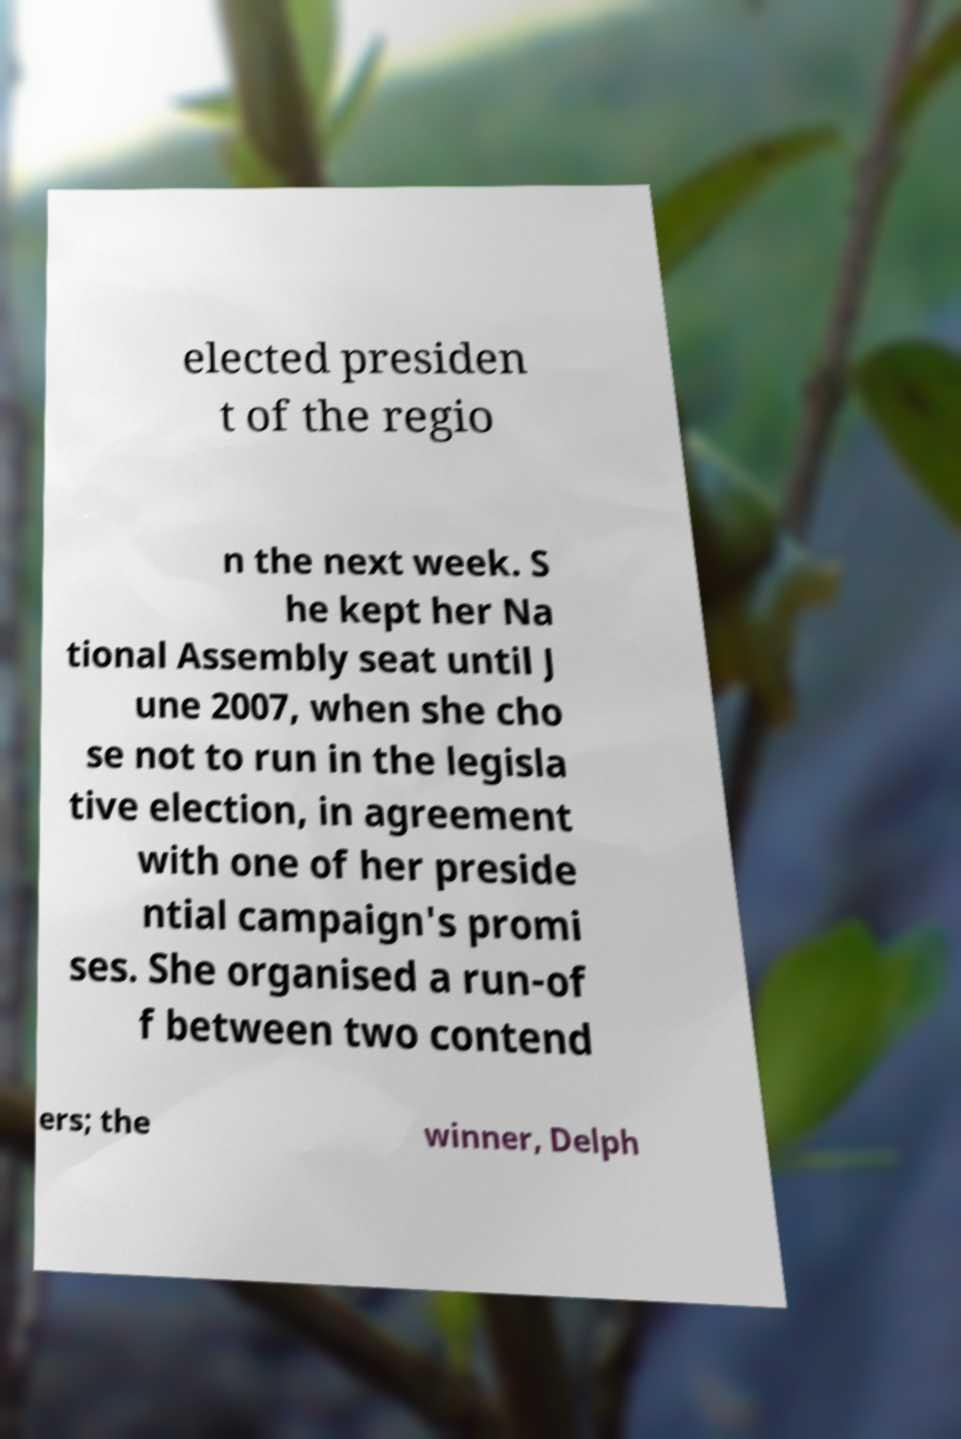Could you extract and type out the text from this image? elected presiden t of the regio n the next week. S he kept her Na tional Assembly seat until J une 2007, when she cho se not to run in the legisla tive election, in agreement with one of her preside ntial campaign's promi ses. She organised a run-of f between two contend ers; the winner, Delph 